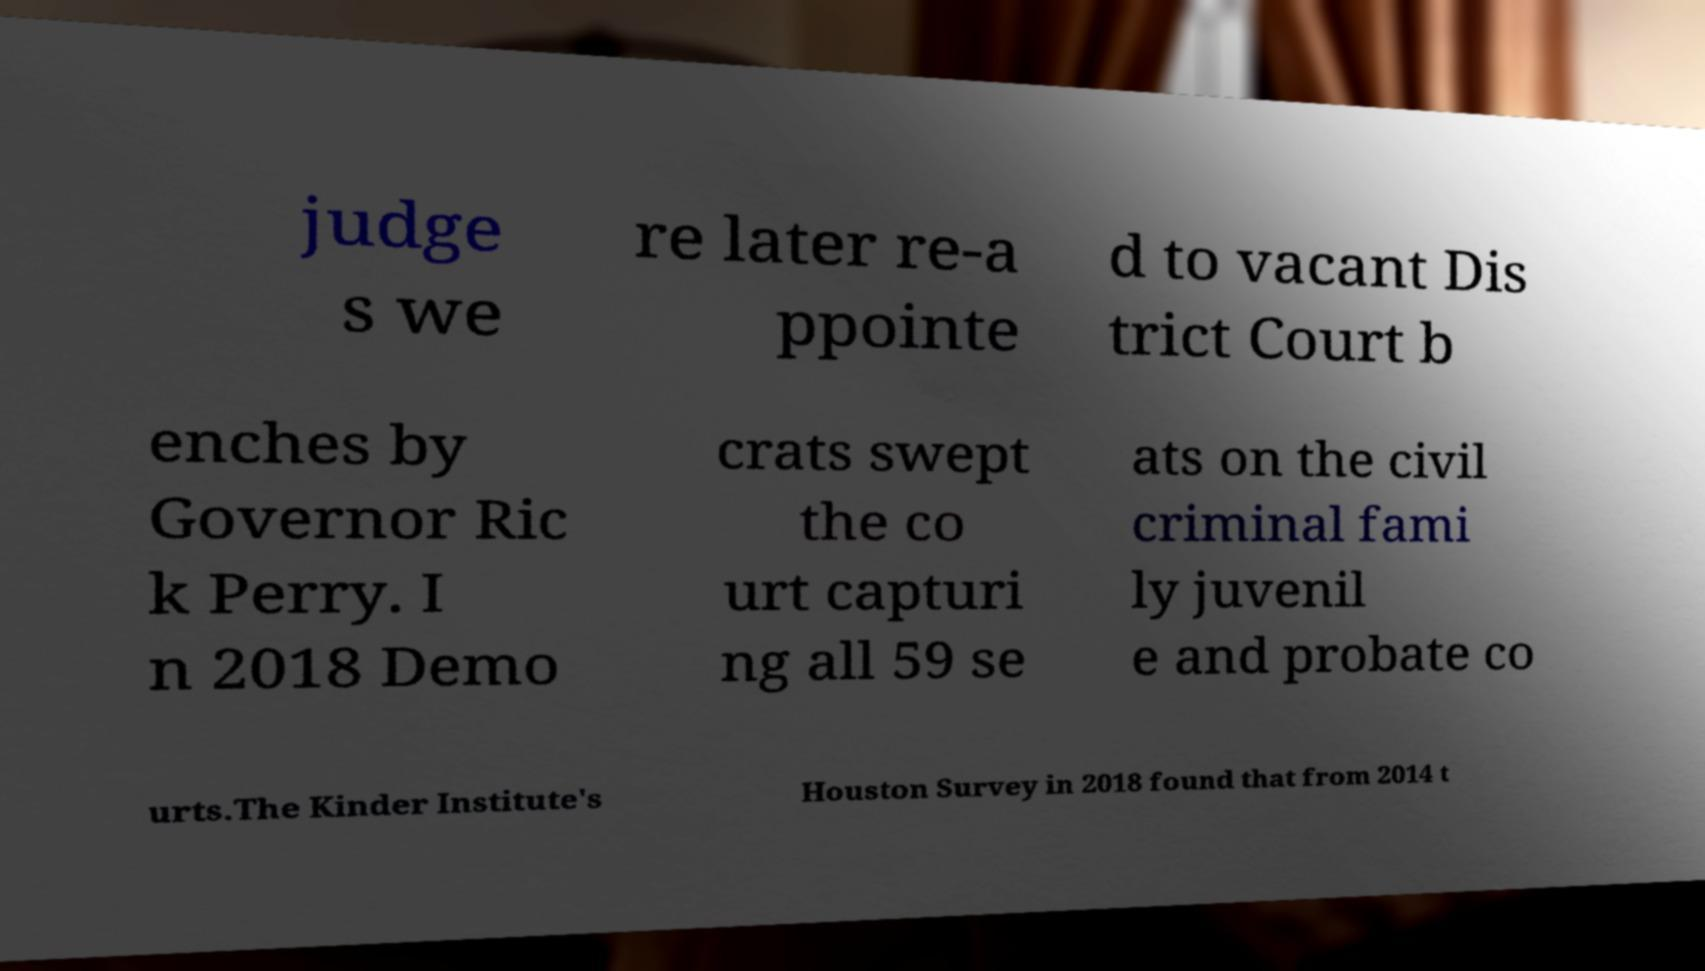For documentation purposes, I need the text within this image transcribed. Could you provide that? judge s we re later re-a ppointe d to vacant Dis trict Court b enches by Governor Ric k Perry. I n 2018 Demo crats swept the co urt capturi ng all 59 se ats on the civil criminal fami ly juvenil e and probate co urts.The Kinder Institute's Houston Survey in 2018 found that from 2014 t 